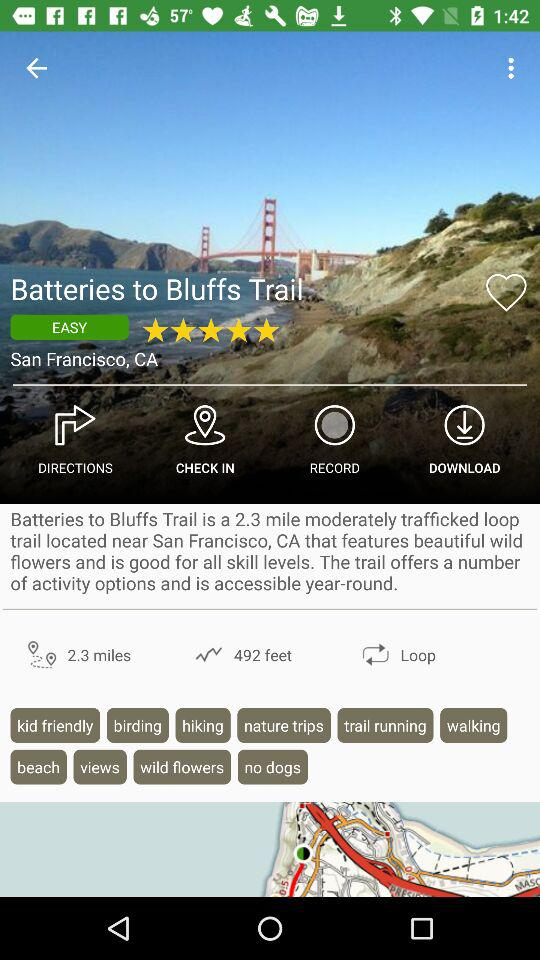By how many hikers, backpackers and mountain bikers is "AllTrails" curated? It is curated by 4 million people. 